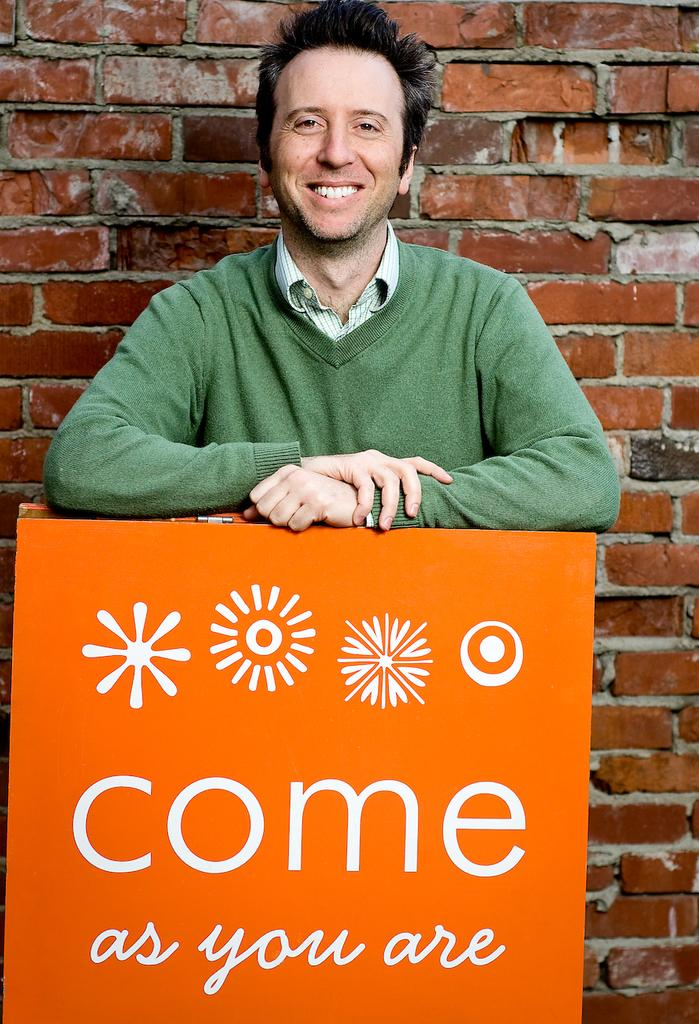What is the main subject of the image? There is a person standing in the image. What is the person standing in front of? The person is standing in front of an orange object. Can you describe the orange object? The orange object has writing on it, using white color. What else can be seen in the background of the image? There is a brick wall visible in the image. How many chickens are sitting on the steel bars in the image? There are no chickens or steel bars present in the image. 